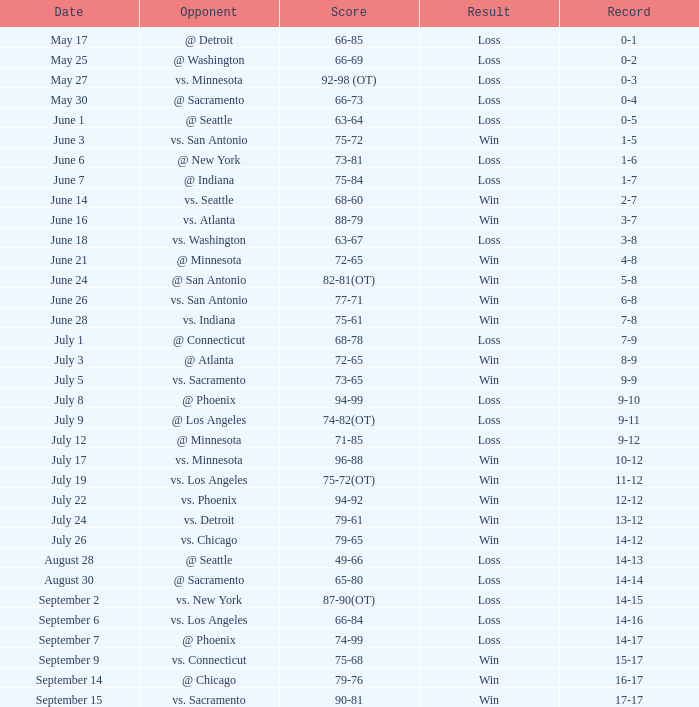What is the date of the match where there was a loss and the record stood at 7-9? July 1. 